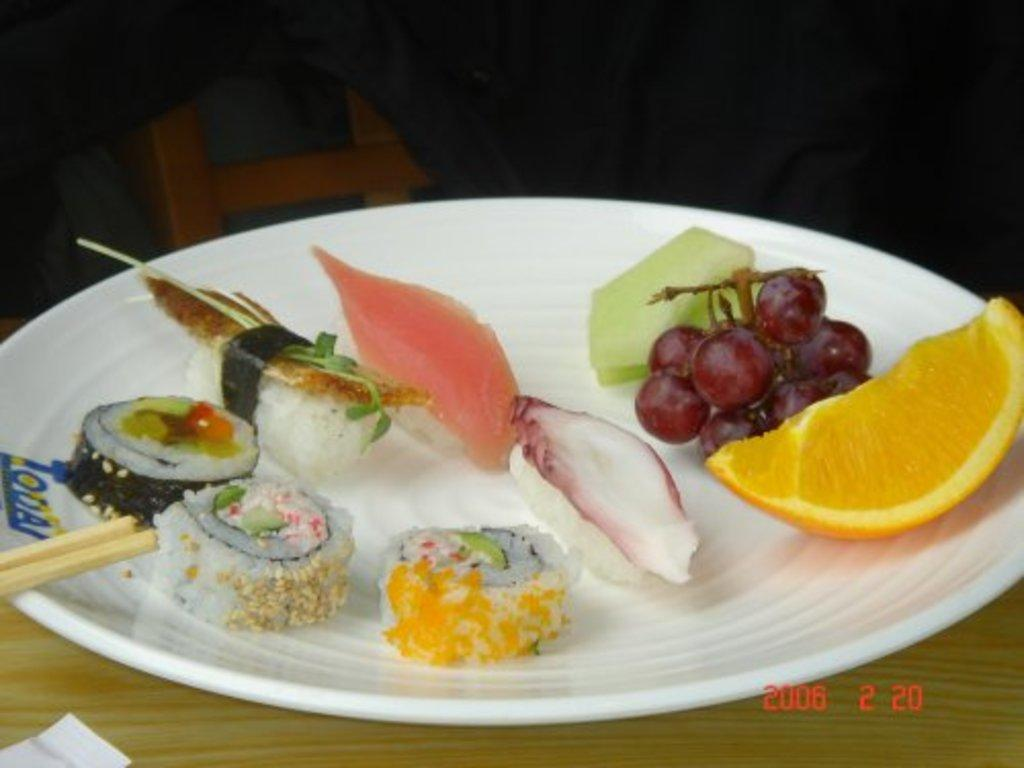What is on the plate that is visible in the image? There is a plate with food items in the image. What type of material is the wooden object made of? The wooden object in the image is made of wood. What can be seen covering or draped over something in the image? Cloth is visible in the image. Where is the object located in the image? The object is on the bottom left of the image. What can be found in the image that contains written words or symbols? There is text present in the image. What decision does the sun make in the image? The image does not contain any representation of the sun, so it is not possible to answer this question. 